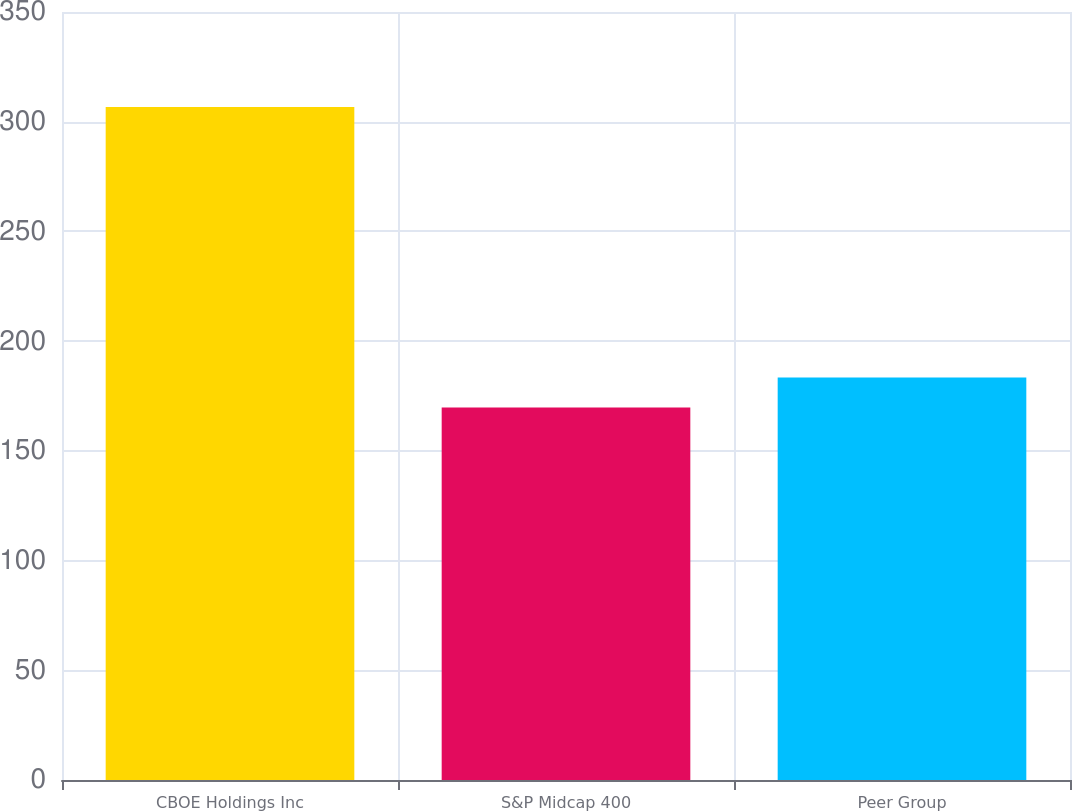Convert chart. <chart><loc_0><loc_0><loc_500><loc_500><bar_chart><fcel>CBOE Holdings Inc<fcel>S&P Midcap 400<fcel>Peer Group<nl><fcel>306.68<fcel>169.75<fcel>183.44<nl></chart> 